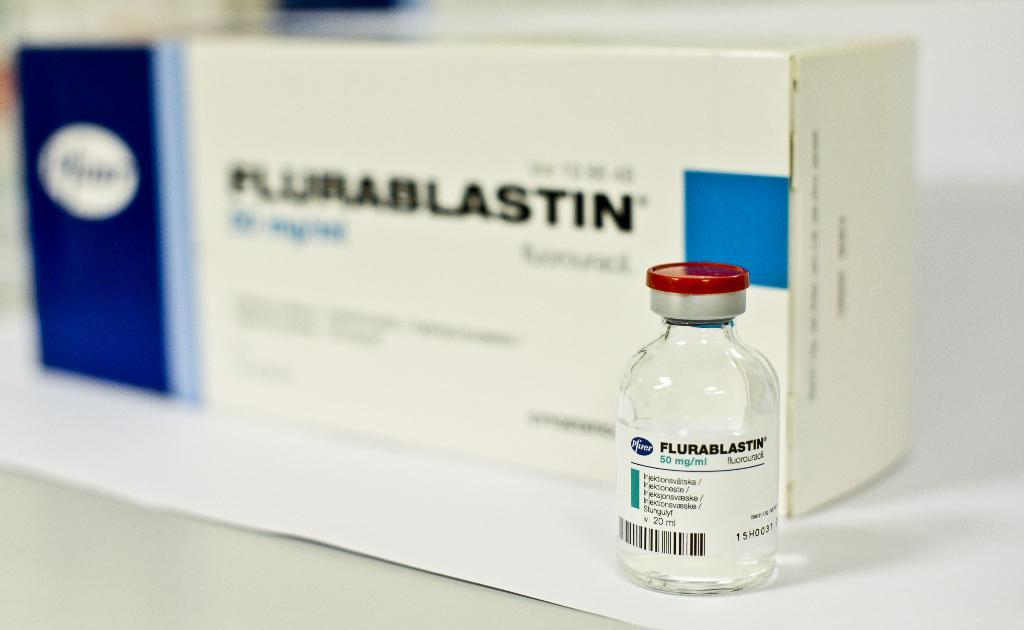<image>
Provide a brief description of the given image. A bottle of Flurablastin sits in front of it's box. 